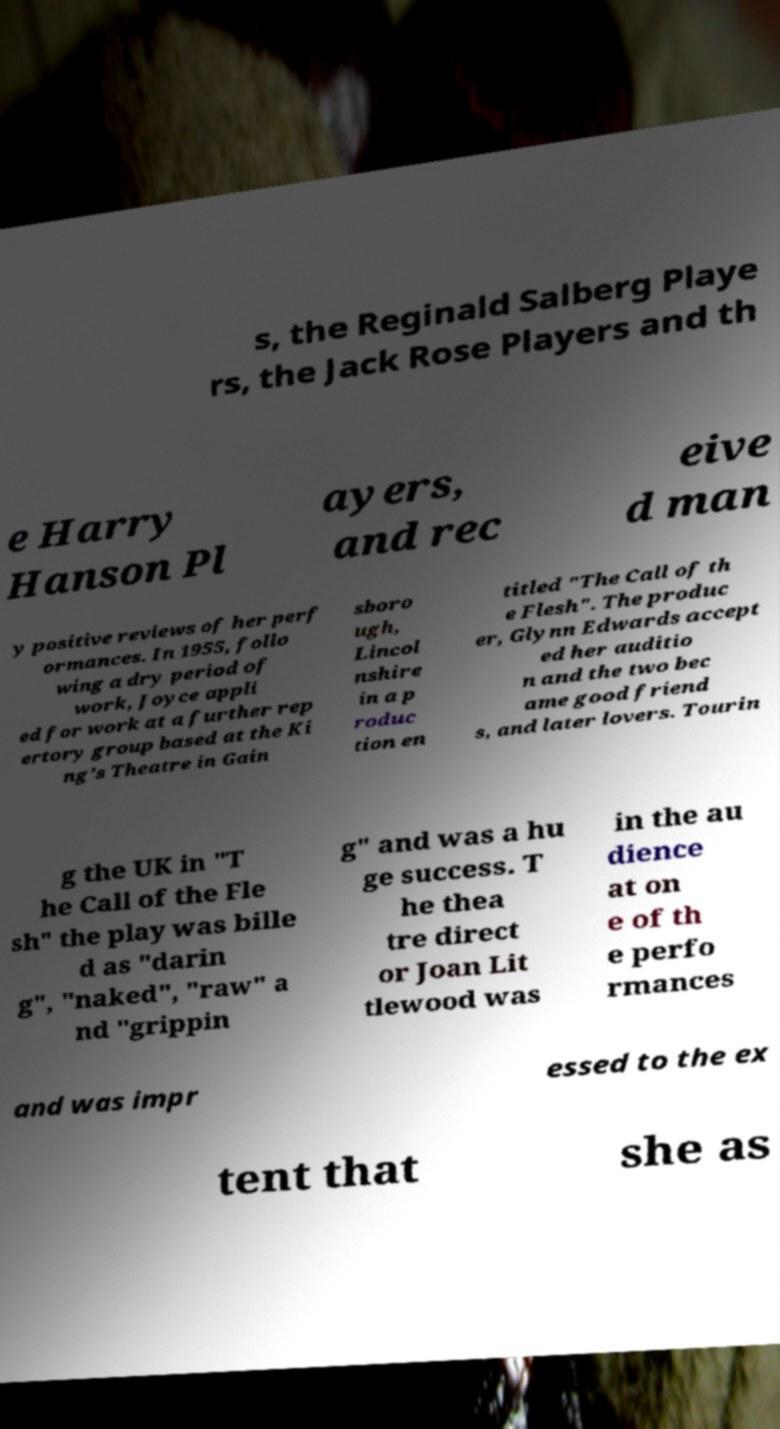For documentation purposes, I need the text within this image transcribed. Could you provide that? s, the Reginald Salberg Playe rs, the Jack Rose Players and th e Harry Hanson Pl ayers, and rec eive d man y positive reviews of her perf ormances. In 1955, follo wing a dry period of work, Joyce appli ed for work at a further rep ertory group based at the Ki ng's Theatre in Gain sboro ugh, Lincol nshire in a p roduc tion en titled "The Call of th e Flesh". The produc er, Glynn Edwards accept ed her auditio n and the two bec ame good friend s, and later lovers. Tourin g the UK in "T he Call of the Fle sh" the play was bille d as "darin g", "naked", "raw" a nd "grippin g" and was a hu ge success. T he thea tre direct or Joan Lit tlewood was in the au dience at on e of th e perfo rmances and was impr essed to the ex tent that she as 